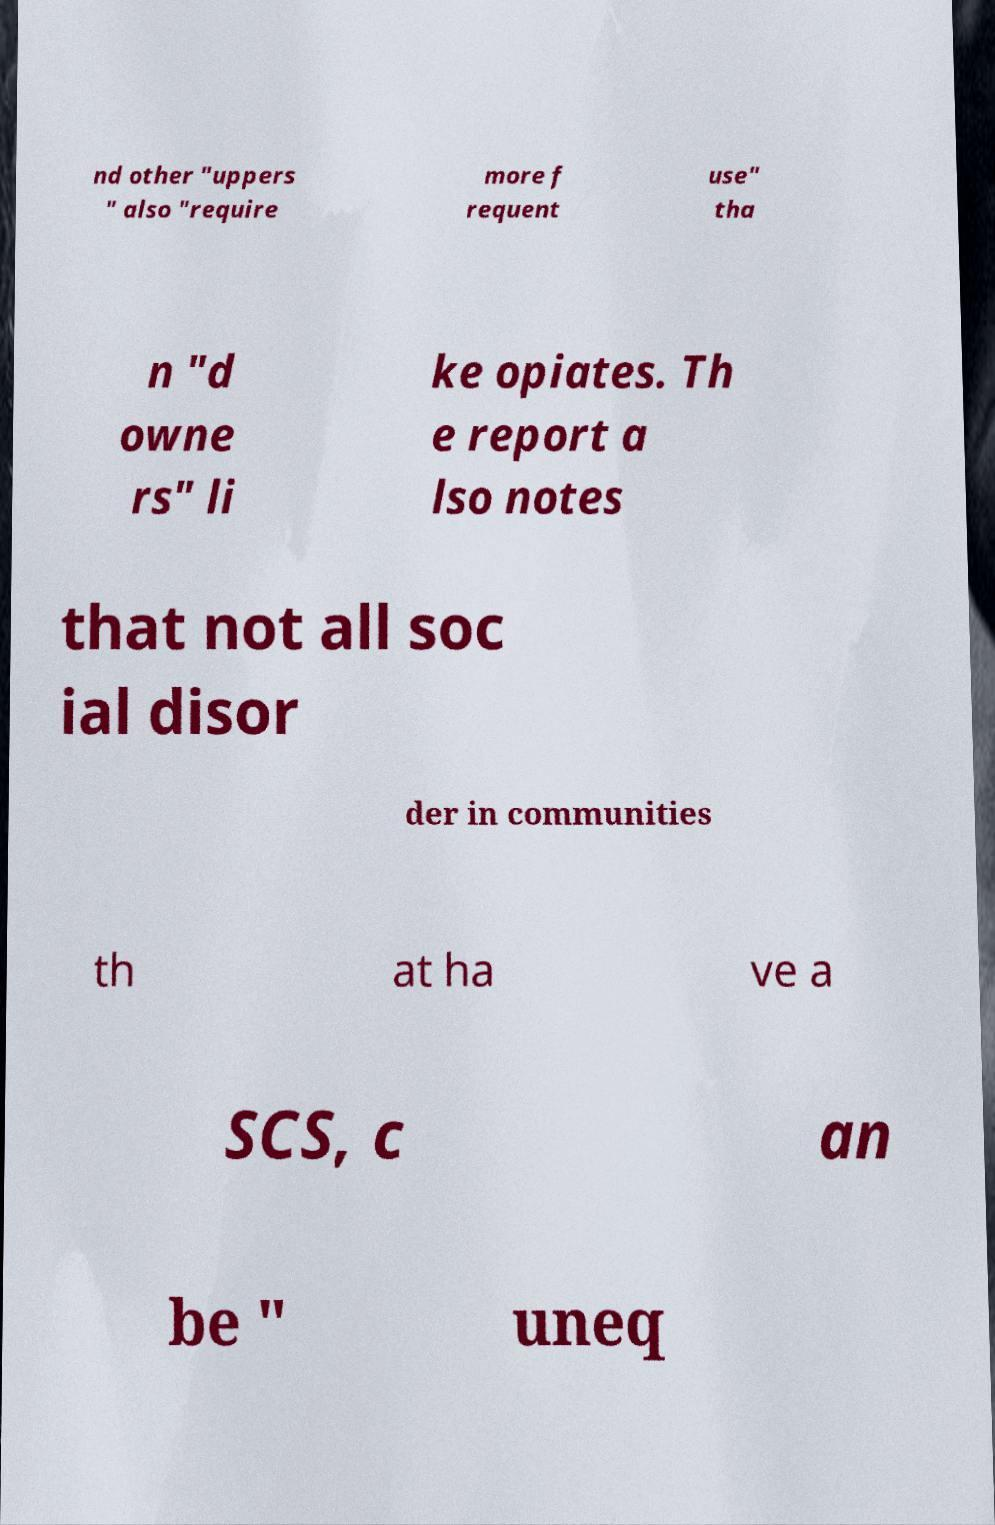Can you accurately transcribe the text from the provided image for me? nd other "uppers " also "require more f requent use" tha n "d owne rs" li ke opiates. Th e report a lso notes that not all soc ial disor der in communities th at ha ve a SCS, c an be " uneq 